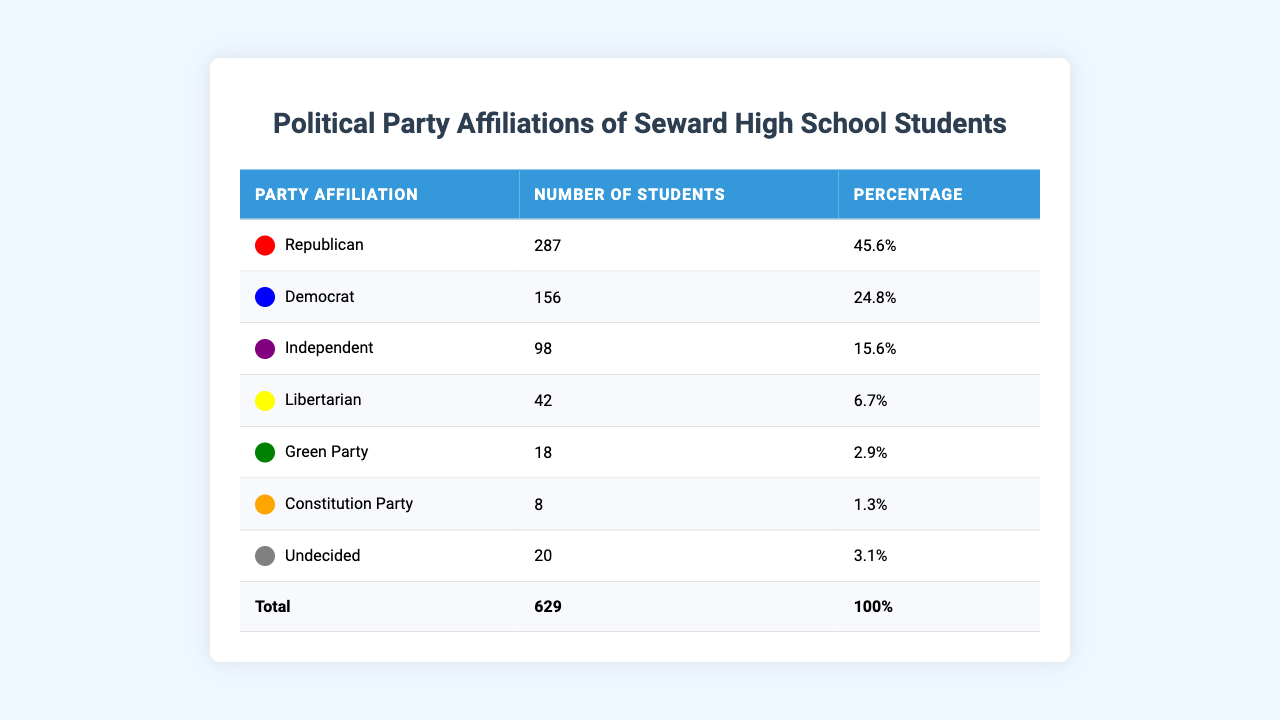What is the largest political party affiliation among Seward High School students? According to the table, the Republican party has the highest number of students affiliated with it, totaling 287 members.
Answer: Republican How many students identify as Independent? The table indicates that 98 students identify as Independent.
Answer: 98 What percentage of the student body are Democrats? The table shows that Democrats make up 24.8% of Seward High School's student body.
Answer: 24.8% What is the total number of students who identify with the Green Party and the Constitution Party combined? The Green Party has 18 students and the Constitution Party has 8 students. Adding these together gives 18 + 8 = 26.
Answer: 26 Is there a larger percentage of students who are Undecided or Libertarian? The table shows that Undecided students account for 3.1% while Libertarians account for 6.7%. Since 6.7% is greater than 3.1%, there is a larger percentage of Libertarians.
Answer: Yes What fraction of the total number of students are affiliated with the Republican Party? The table states there are 629 total students, and 287 of them are Republicans. The fraction is 287/629. To simplify, this can be calculated, but it stays as is for the answer.
Answer: 287/629 Which political party has the lowest number of students? The data indicates that the Constitution Party, with 8 students, has the lowest number of any party.
Answer: Constitution Party If you combine the number of Republican and Democratic students, how many do you have? The number of Republican students is 287, and the number of Democratic students is 156. Adding these together gives 287 + 156 = 443.
Answer: 443 What percentage of the student body is affiliated with parties other than the Republican Party? The Republican party has 45.6%, so to find the remaining percentage for other parties, we subtract this from 100%: 100% - 45.6% = 54.4%.
Answer: 54.4% How many more students are Republicans than Libertarians? The table shows there are 287 Republicans and 42 Libertarians. The difference is calculated by subtracting: 287 - 42 = 245.
Answer: 245 